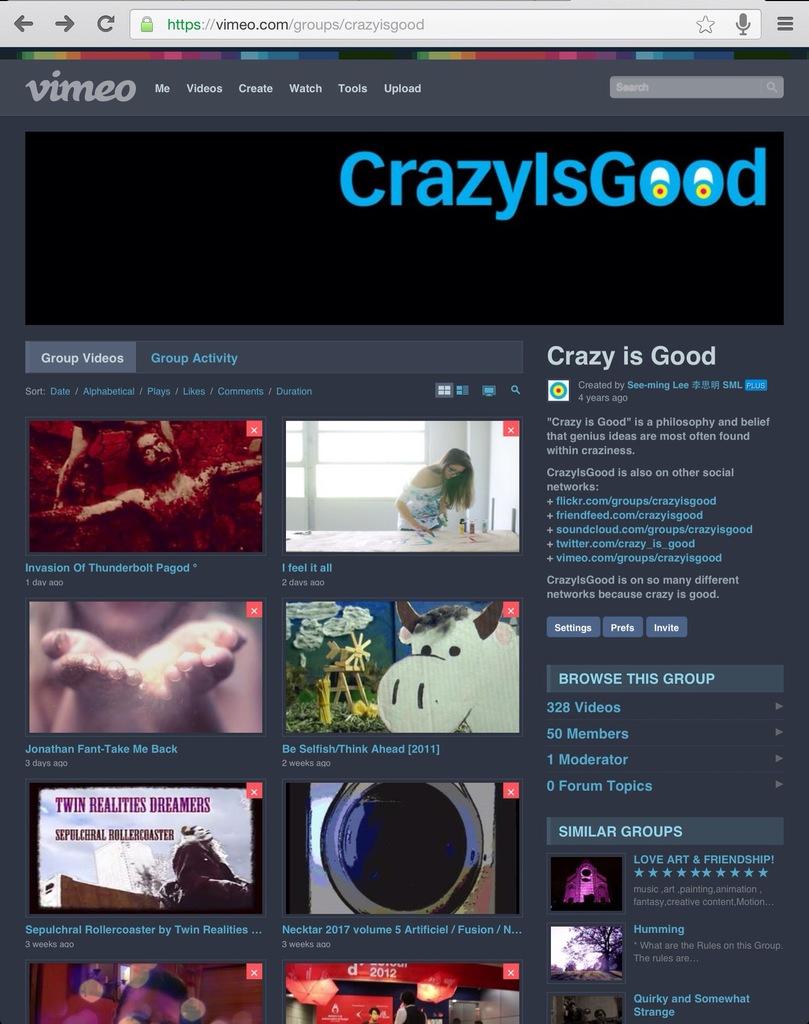What is the website showing?
Make the answer very short. Crazy is good. What website is this?
Offer a very short reply. Vimeo. 